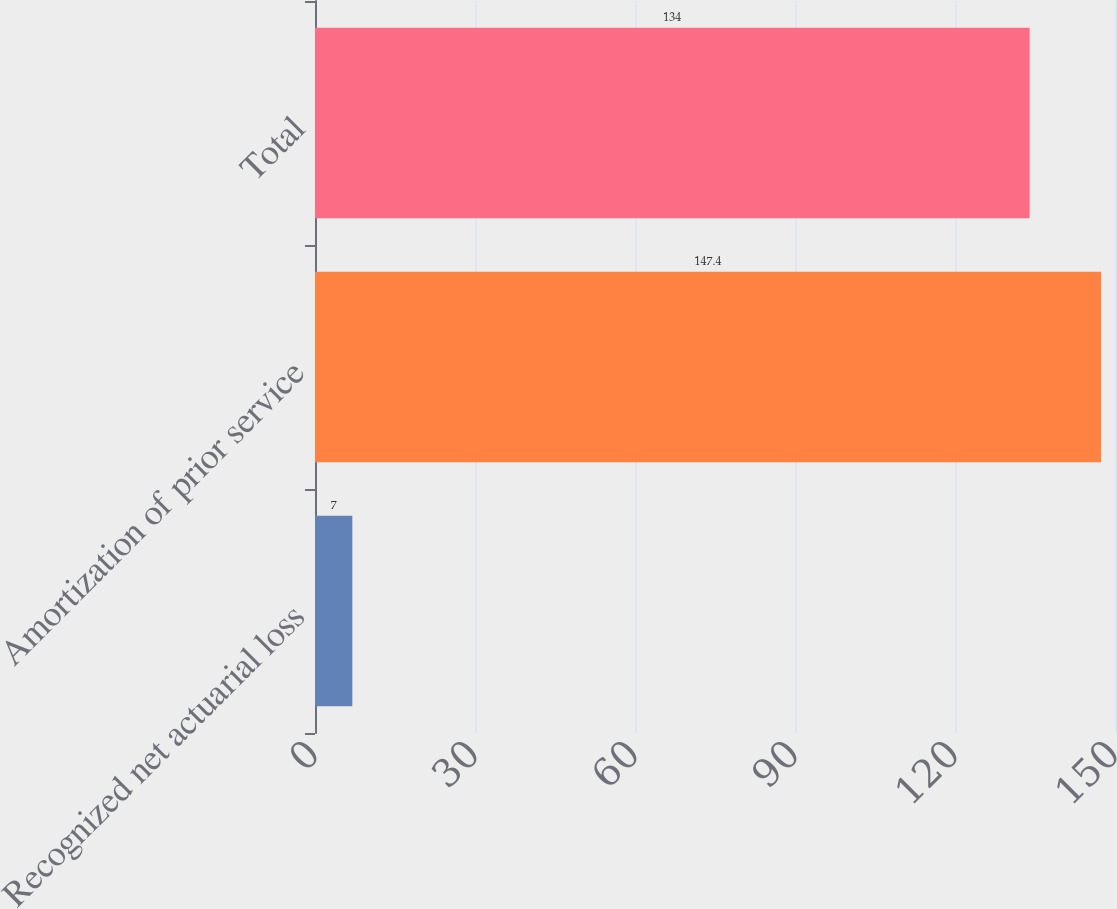Convert chart to OTSL. <chart><loc_0><loc_0><loc_500><loc_500><bar_chart><fcel>Recognized net actuarial loss<fcel>Amortization of prior service<fcel>Total<nl><fcel>7<fcel>147.4<fcel>134<nl></chart> 